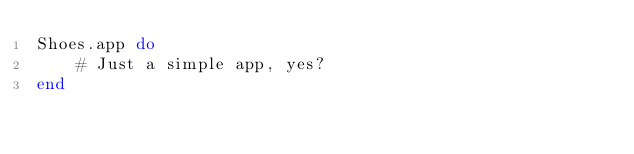Convert code to text. <code><loc_0><loc_0><loc_500><loc_500><_Ruby_>Shoes.app do
	# Just a simple app, yes?
end
</code> 